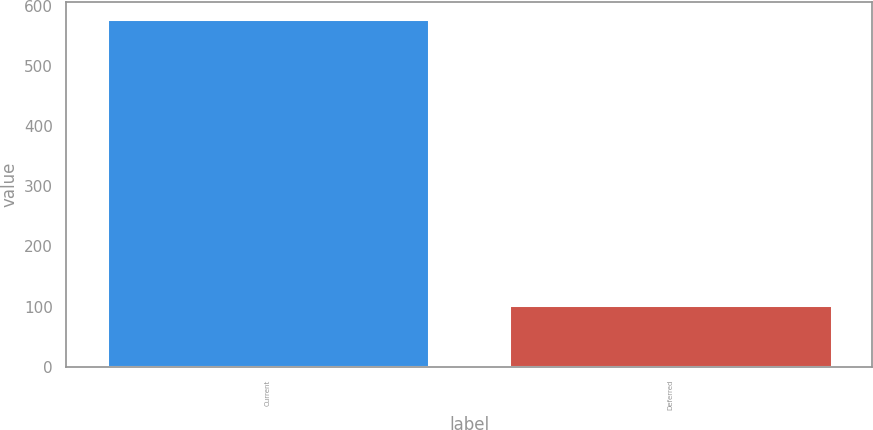Convert chart to OTSL. <chart><loc_0><loc_0><loc_500><loc_500><bar_chart><fcel>Current<fcel>Deferred<nl><fcel>577<fcel>103<nl></chart> 